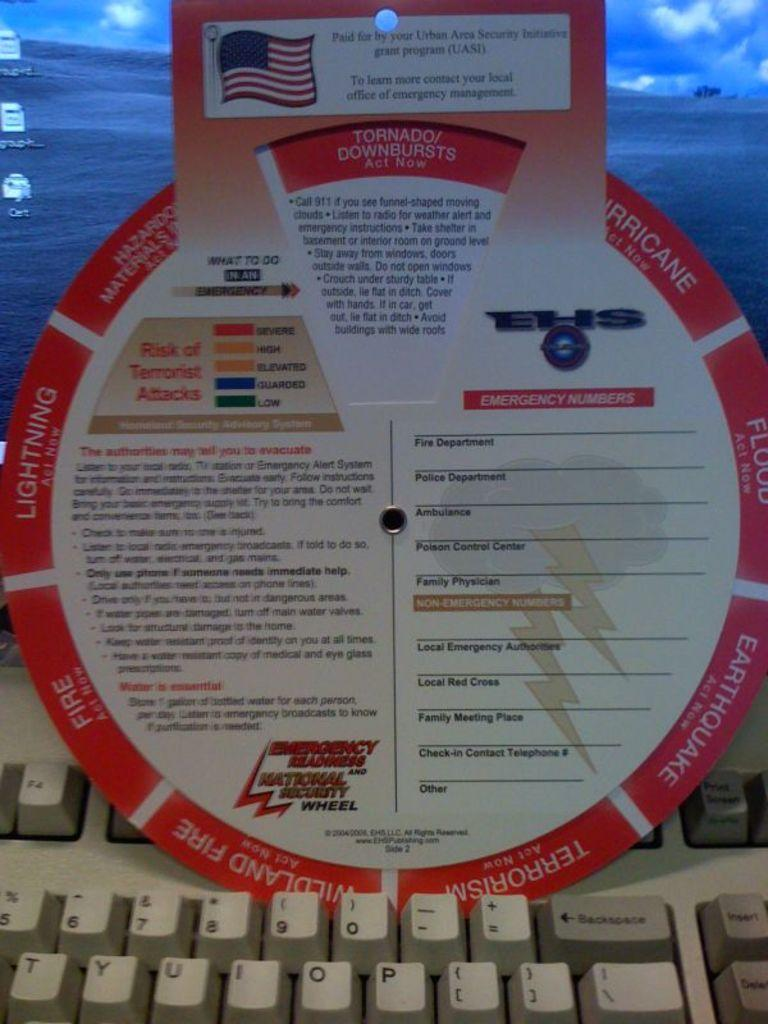<image>
Summarize the visual content of the image. one emergency readiness wheel sitting on a computer keyboard 